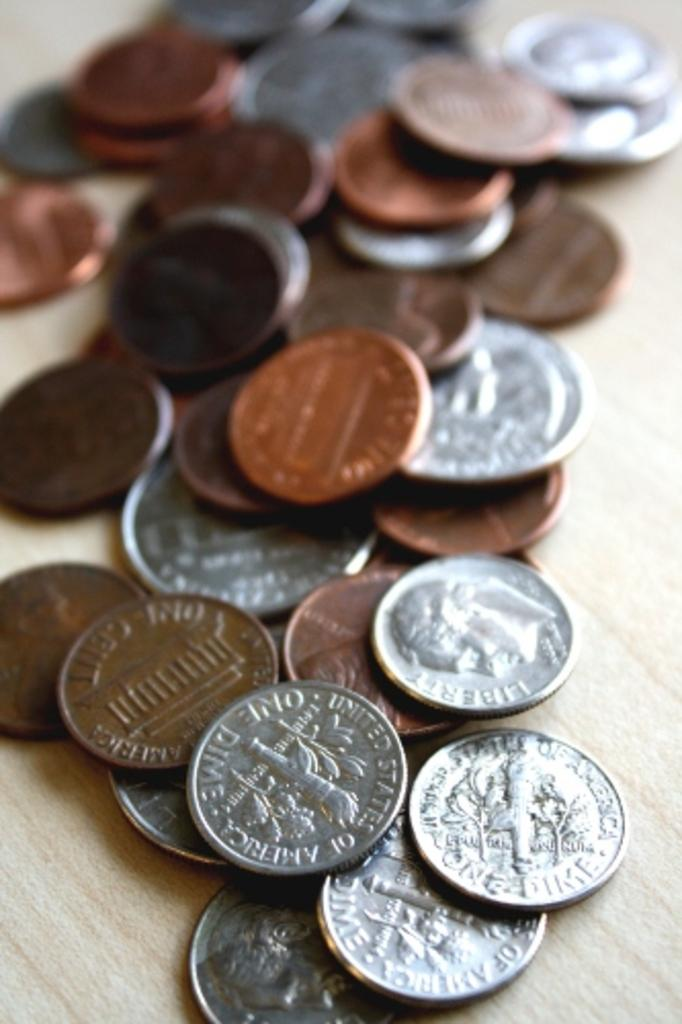<image>
Create a compact narrative representing the image presented. A bunch of American coins including dimes, pennies, nickels and quarters. 